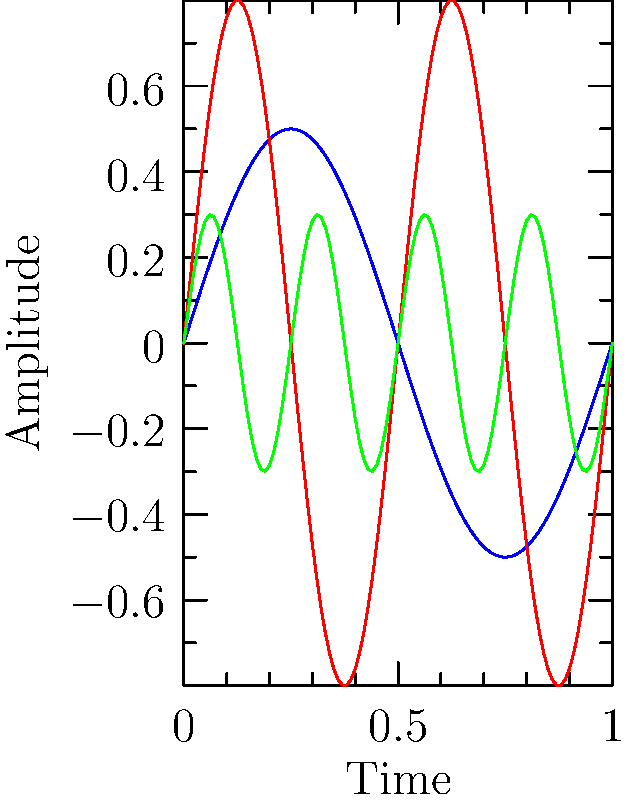Analyze the waveforms representing three different types of rare audio recordings: vinyl, wax cylinder, and wire recording. Which format appears to have the highest frequency based on the number of cycles completed within the given time frame? To determine which format has the highest frequency, we need to examine the number of cycles completed by each waveform within the given time frame. Let's analyze each waveform:

1. Vinyl (blue line):
   - Completes approximately 1 full cycle in the given time frame.
   - Has the lowest frequency among the three.

2. Wax Cylinder (red line):
   - Completes about 2 full cycles in the given time frame.
   - Has a higher frequency than vinyl but lower than wire recording.

3. Wire Recording (green line):
   - Completes approximately 4 full cycles in the given time frame.
   - Has the highest frequency among the three.

The frequency of a waveform is directly related to the number of cycles completed in a given time. More cycles in the same time frame indicate a higher frequency.

In this case, the wire recording (green line) clearly shows the most cycles completed within the given time frame, indicating that it has the highest frequency among the three formats.
Answer: Wire Recording 